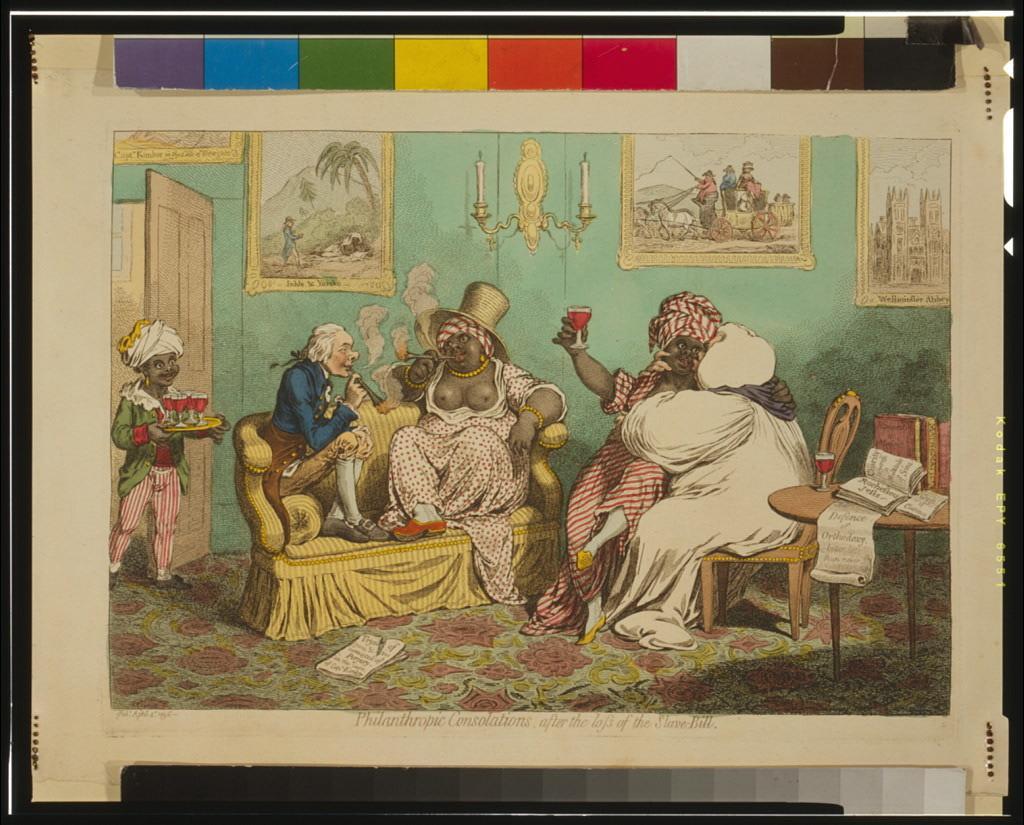Please provide a concise description of this image. This image is a painting. In the center of the image we can see a persons sitting on the sofa. On the right side of the image we can see two person sitting on the chairs, table, books, pillows, photo frames. On the left side of the image there is a person coming from the door. In the background there is a wall and candles. 